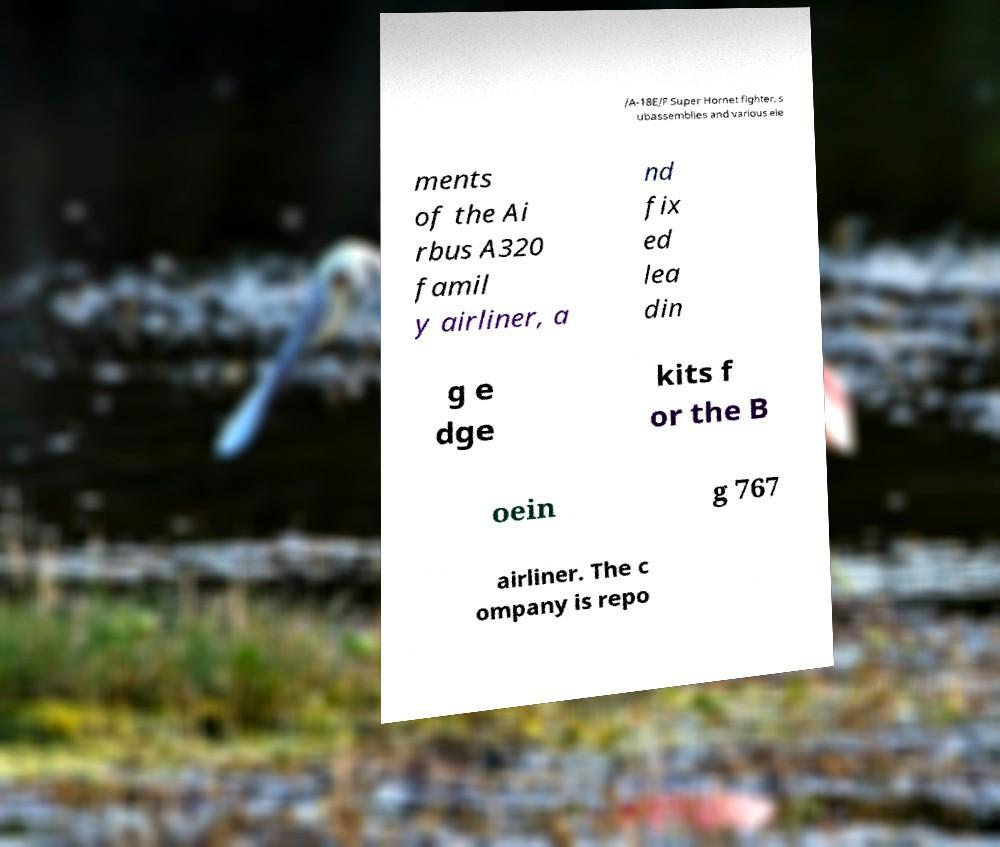I need the written content from this picture converted into text. Can you do that? /A-18E/F Super Hornet fighter, s ubassemblies and various ele ments of the Ai rbus A320 famil y airliner, a nd fix ed lea din g e dge kits f or the B oein g 767 airliner. The c ompany is repo 